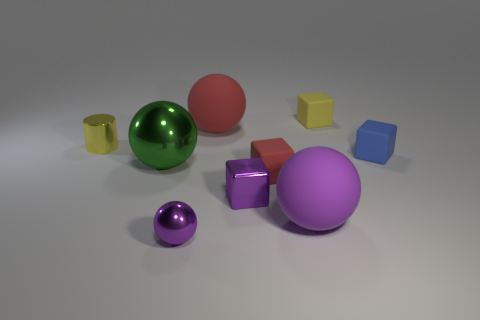Subtract all cubes. How many objects are left? 5 Subtract 0 red cylinders. How many objects are left? 9 Subtract all blocks. Subtract all tiny balls. How many objects are left? 4 Add 7 large spheres. How many large spheres are left? 10 Add 9 purple matte things. How many purple matte things exist? 10 